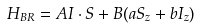Convert formula to latex. <formula><loc_0><loc_0><loc_500><loc_500>H _ { B R } = A I \cdot S + B ( a S _ { z } + b I _ { z } )</formula> 